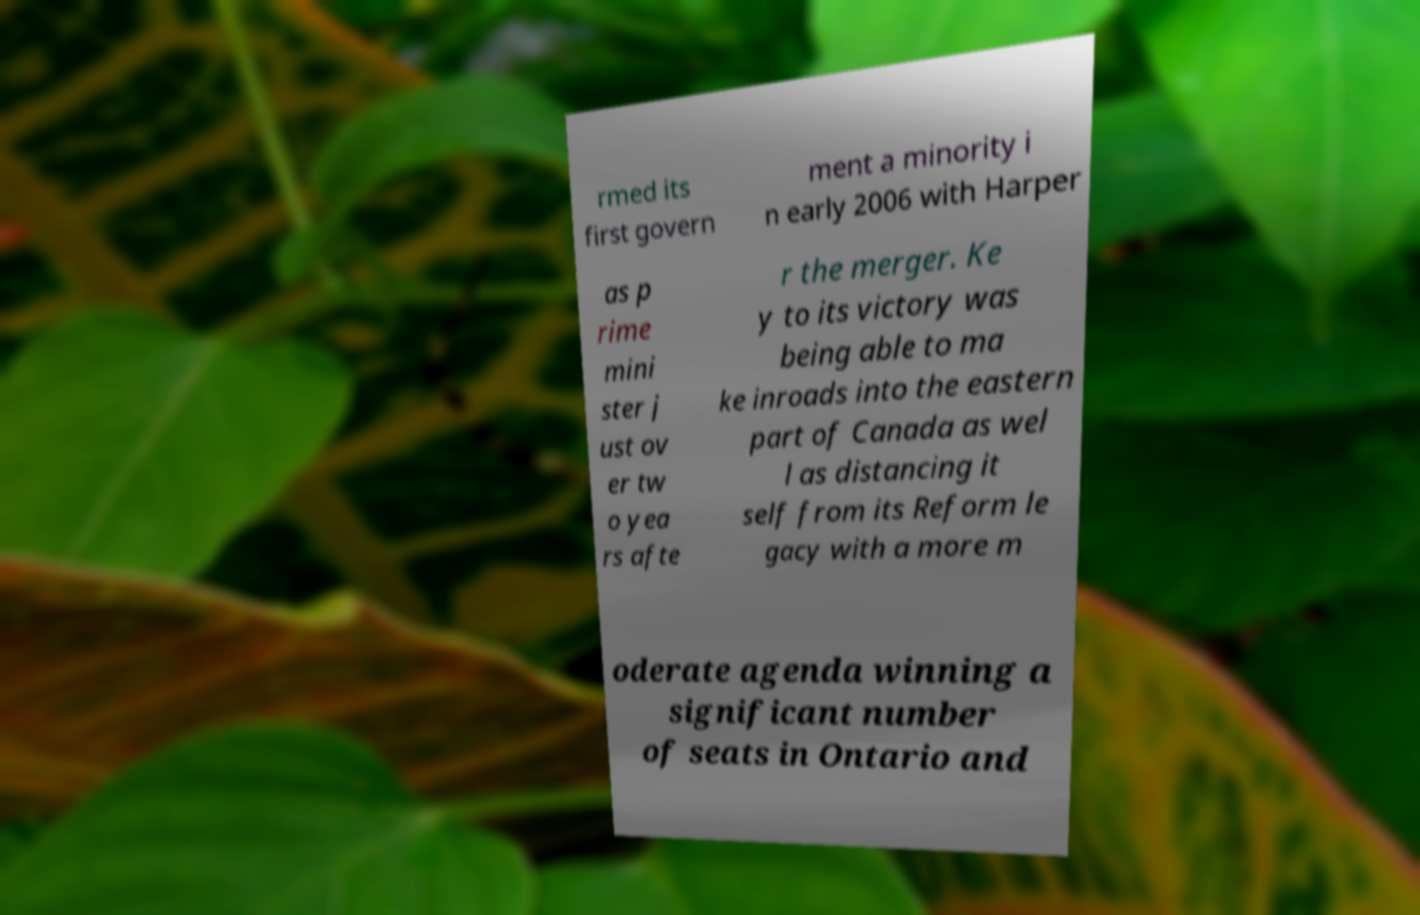For documentation purposes, I need the text within this image transcribed. Could you provide that? rmed its first govern ment a minority i n early 2006 with Harper as p rime mini ster j ust ov er tw o yea rs afte r the merger. Ke y to its victory was being able to ma ke inroads into the eastern part of Canada as wel l as distancing it self from its Reform le gacy with a more m oderate agenda winning a significant number of seats in Ontario and 